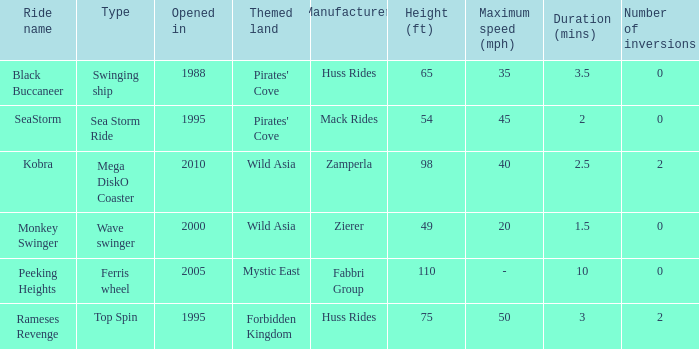Can you give me this table as a dict? {'header': ['Ride name', 'Type', 'Opened in', 'Themed land', 'Manufacturer', 'Height (ft)', 'Maximum speed (mph)', 'Duration (mins)', 'Number of inversions'], 'rows': [['Black Buccaneer', 'Swinging ship', '1988', "Pirates' Cove", 'Huss Rides', '65', '35', '3.5', '0'], ['SeaStorm', 'Sea Storm Ride', '1995', "Pirates' Cove", 'Mack Rides', '54', '45', '2', '0'], ['Kobra', 'Mega DiskO Coaster', '2010', 'Wild Asia', 'Zamperla', '98', '40', '2.5', '2'], ['Monkey Swinger', 'Wave swinger', '2000', 'Wild Asia', 'Zierer', '49', '20', '1.5', '0'], ['Peeking Heights', 'Ferris wheel', '2005', 'Mystic East', 'Fabbri Group', '110', '-', '10', '0'], ['Rameses Revenge', 'Top Spin', '1995', 'Forbidden Kingdom', 'Huss Rides', '75', '50', '3', '2']]} What ride was manufactured by Zierer? Monkey Swinger. 